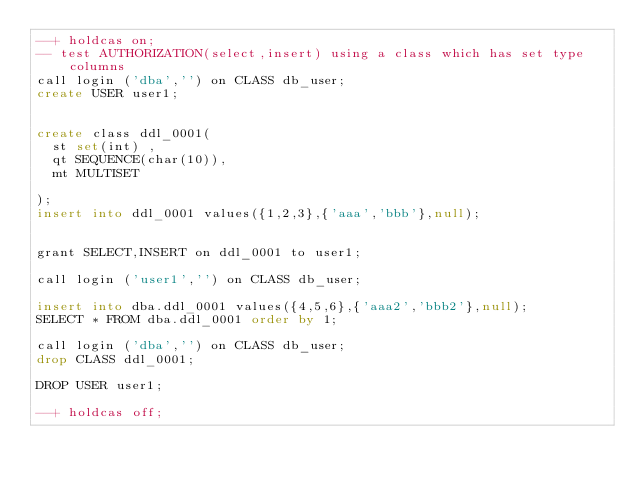Convert code to text. <code><loc_0><loc_0><loc_500><loc_500><_SQL_>--+ holdcas on;
-- test AUTHORIZATION(select,insert) using a class which has set type columns
call login ('dba','') on CLASS db_user;
create USER user1;


create class ddl_0001(
	st set(int) ,
	qt SEQUENCE(char(10)),
	mt MULTISET

);
insert into ddl_0001 values({1,2,3},{'aaa','bbb'},null);


grant SELECT,INSERT on ddl_0001 to user1;

call login ('user1','') on CLASS db_user;

insert into dba.ddl_0001 values({4,5,6},{'aaa2','bbb2'},null);
SELECT * FROM dba.ddl_0001 order by 1;

call login ('dba','') on CLASS db_user;
drop CLASS ddl_0001;

DROP USER user1;

--+ holdcas off;
</code> 